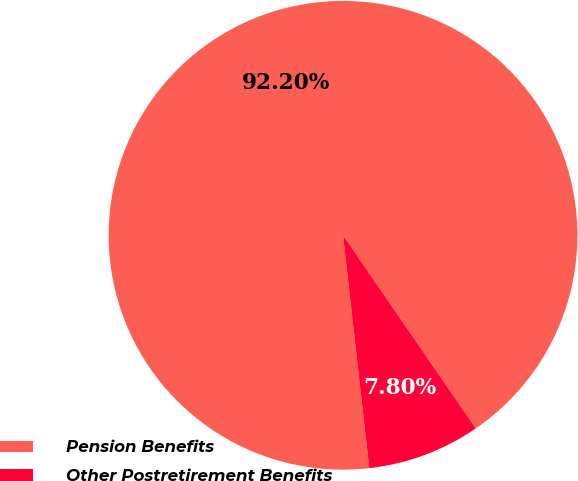Convert chart to OTSL. <chart><loc_0><loc_0><loc_500><loc_500><pie_chart><fcel>Pension Benefits<fcel>Other Postretirement Benefits<nl><fcel>92.2%<fcel>7.8%<nl></chart> 